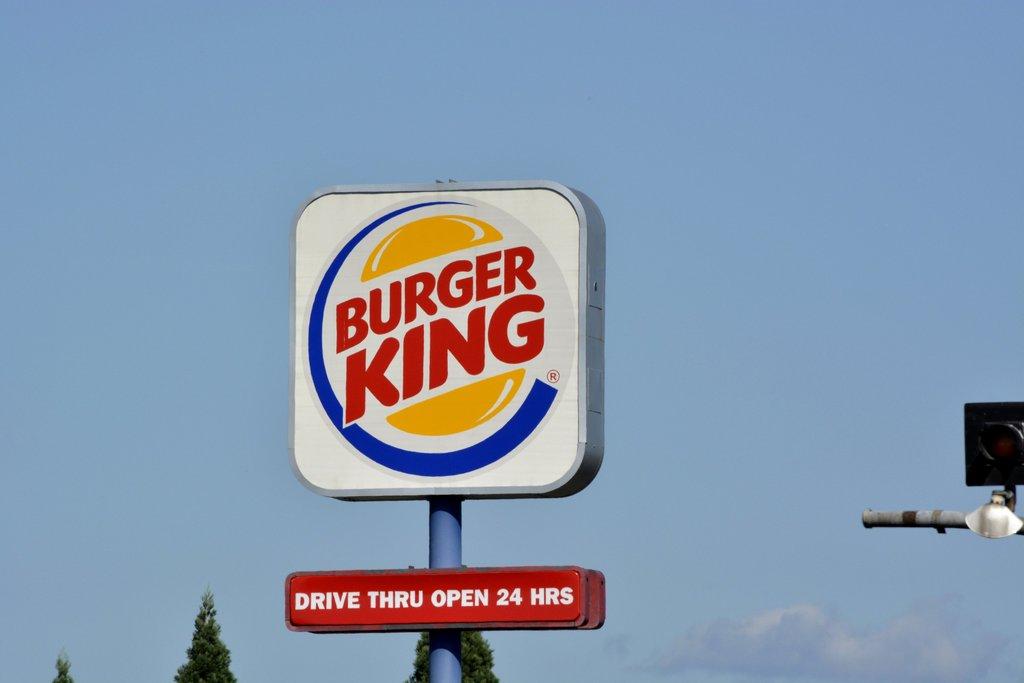What fast food restaurant is the sign for?
Your response must be concise. Burger king. 